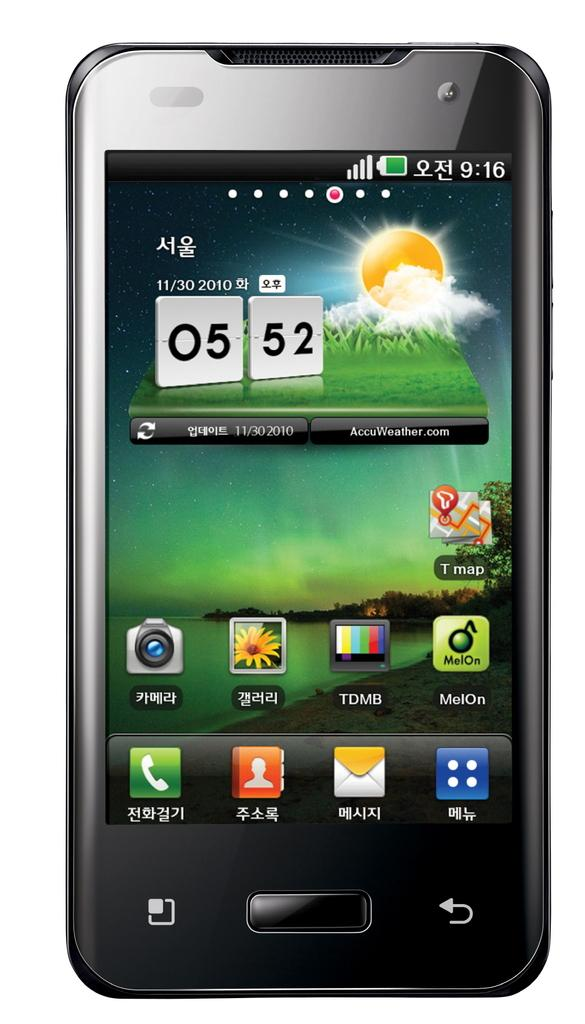<image>
Present a compact description of the photo's key features. A phone is showing the time a 5:52 on November 30th 2010. 